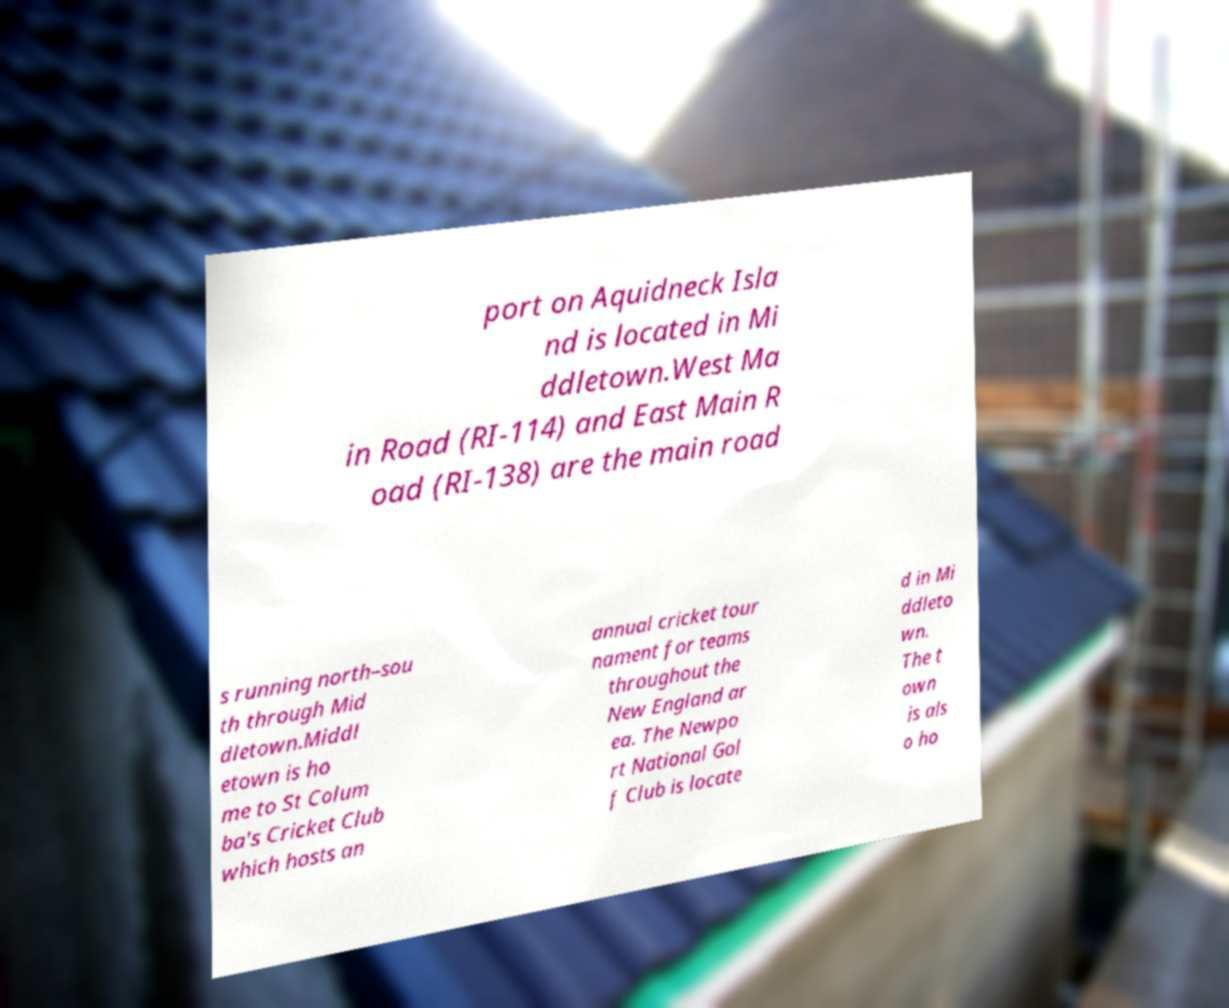There's text embedded in this image that I need extracted. Can you transcribe it verbatim? port on Aquidneck Isla nd is located in Mi ddletown.West Ma in Road (RI-114) and East Main R oad (RI-138) are the main road s running north–sou th through Mid dletown.Middl etown is ho me to St Colum ba's Cricket Club which hosts an annual cricket tour nament for teams throughout the New England ar ea. The Newpo rt National Gol f Club is locate d in Mi ddleto wn. The t own is als o ho 